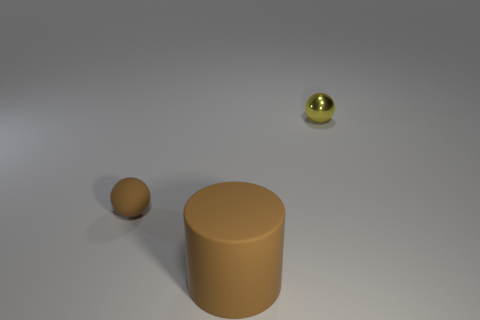There is another thing that is the same color as the big rubber thing; what is its material?
Offer a terse response. Rubber. What is the size of the ball left of the big cylinder that is to the right of the ball left of the metallic thing?
Provide a succinct answer. Small. There is a small brown thing; is its shape the same as the small thing behind the tiny brown rubber ball?
Provide a short and direct response. Yes. Are there any big metal cylinders of the same color as the metal object?
Provide a succinct answer. No. What number of cylinders are brown rubber objects or metallic things?
Make the answer very short. 1. Are there any other small things of the same shape as the tiny brown rubber object?
Make the answer very short. Yes. What number of other objects are there of the same color as the small metal ball?
Make the answer very short. 0. Are there fewer tiny yellow metallic things that are to the left of the big thing than cyan metal things?
Provide a succinct answer. No. How many brown spheres are there?
Keep it short and to the point. 1. What number of other brown objects have the same material as the tiny brown thing?
Ensure brevity in your answer.  1. 